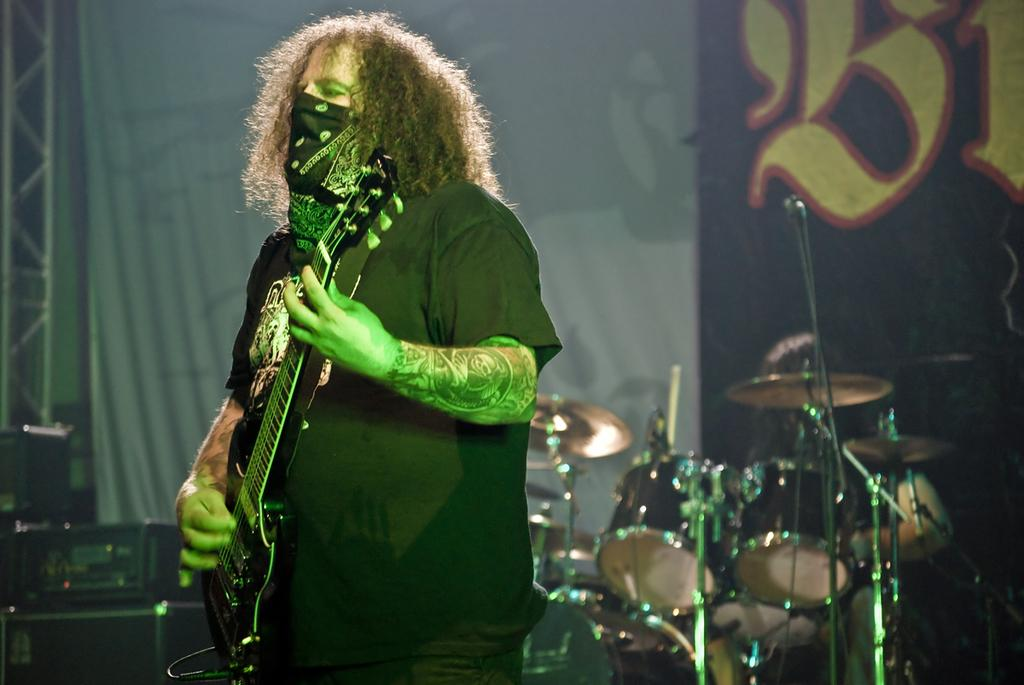What is the man in the image doing? The man is playing a guitar in the image. What other objects can be seen in the image related to the man's activity? There are musical instruments visible in the background of the image. What type of education does the house in the image provide? There is no house present in the image, so it cannot provide any education. 